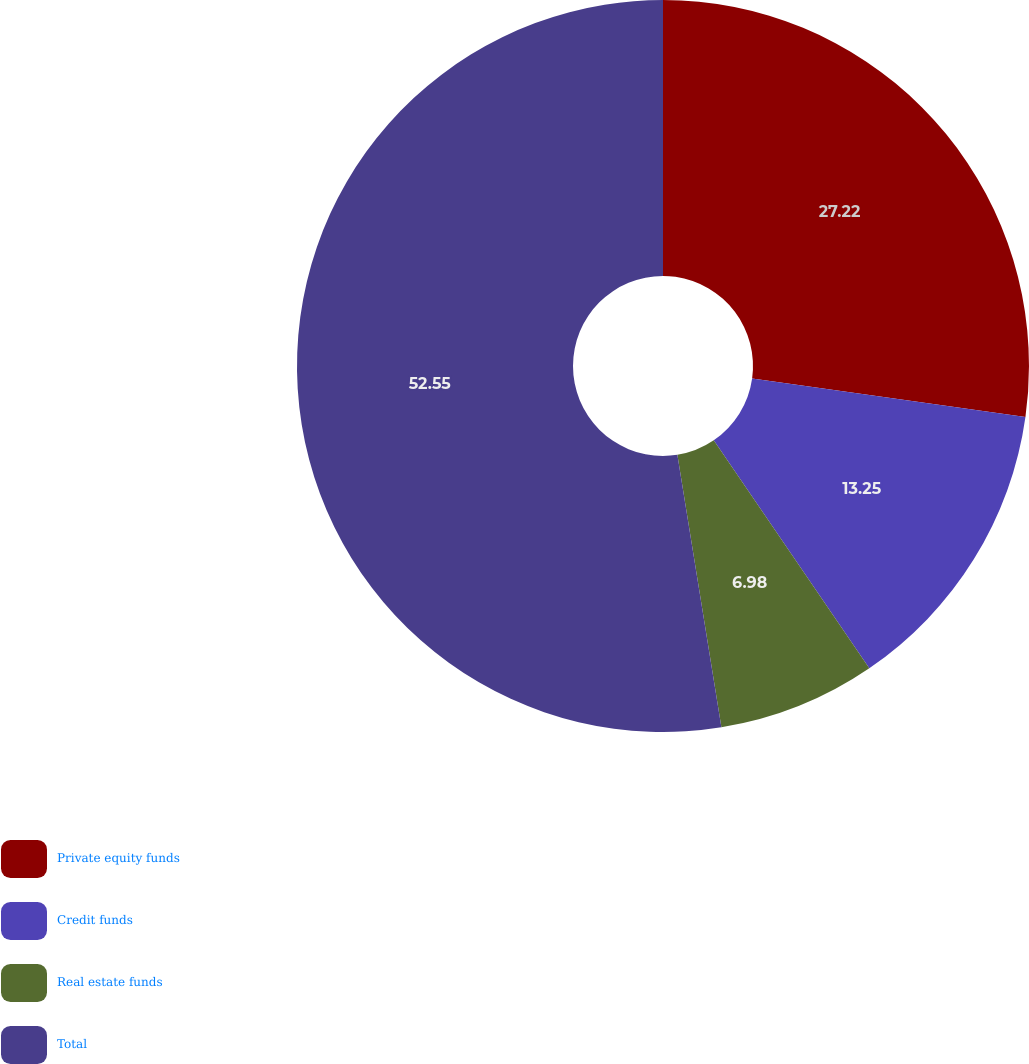<chart> <loc_0><loc_0><loc_500><loc_500><pie_chart><fcel>Private equity funds<fcel>Credit funds<fcel>Real estate funds<fcel>Total<nl><fcel>27.22%<fcel>13.25%<fcel>6.98%<fcel>52.55%<nl></chart> 